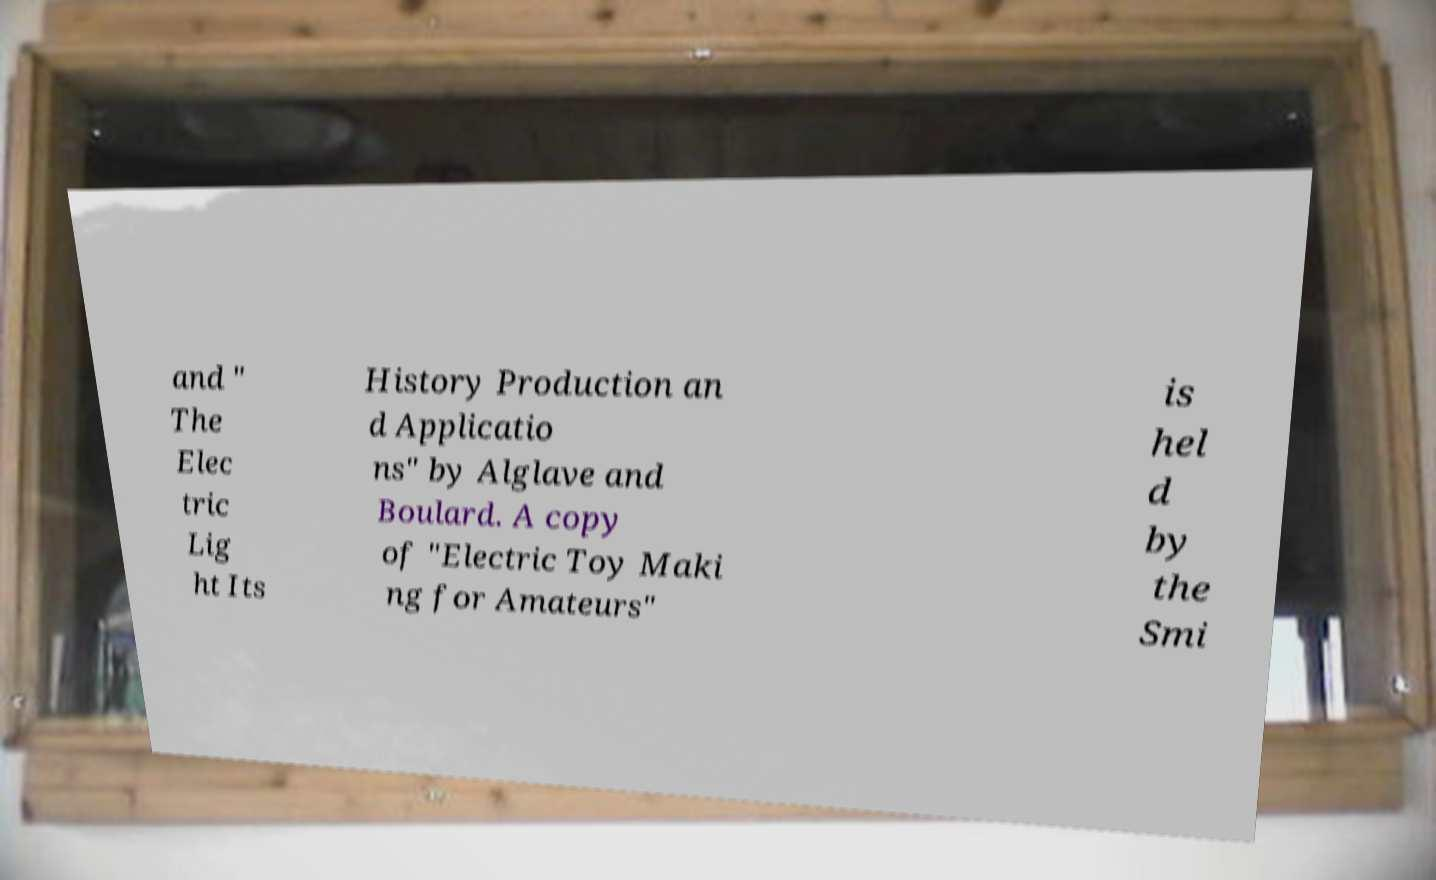There's text embedded in this image that I need extracted. Can you transcribe it verbatim? and " The Elec tric Lig ht Its History Production an d Applicatio ns" by Alglave and Boulard. A copy of "Electric Toy Maki ng for Amateurs" is hel d by the Smi 